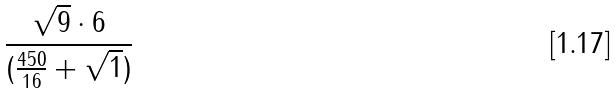<formula> <loc_0><loc_0><loc_500><loc_500>\frac { \sqrt { 9 } \cdot 6 } { ( \frac { 4 5 0 } { 1 6 } + \sqrt { 1 } ) }</formula> 